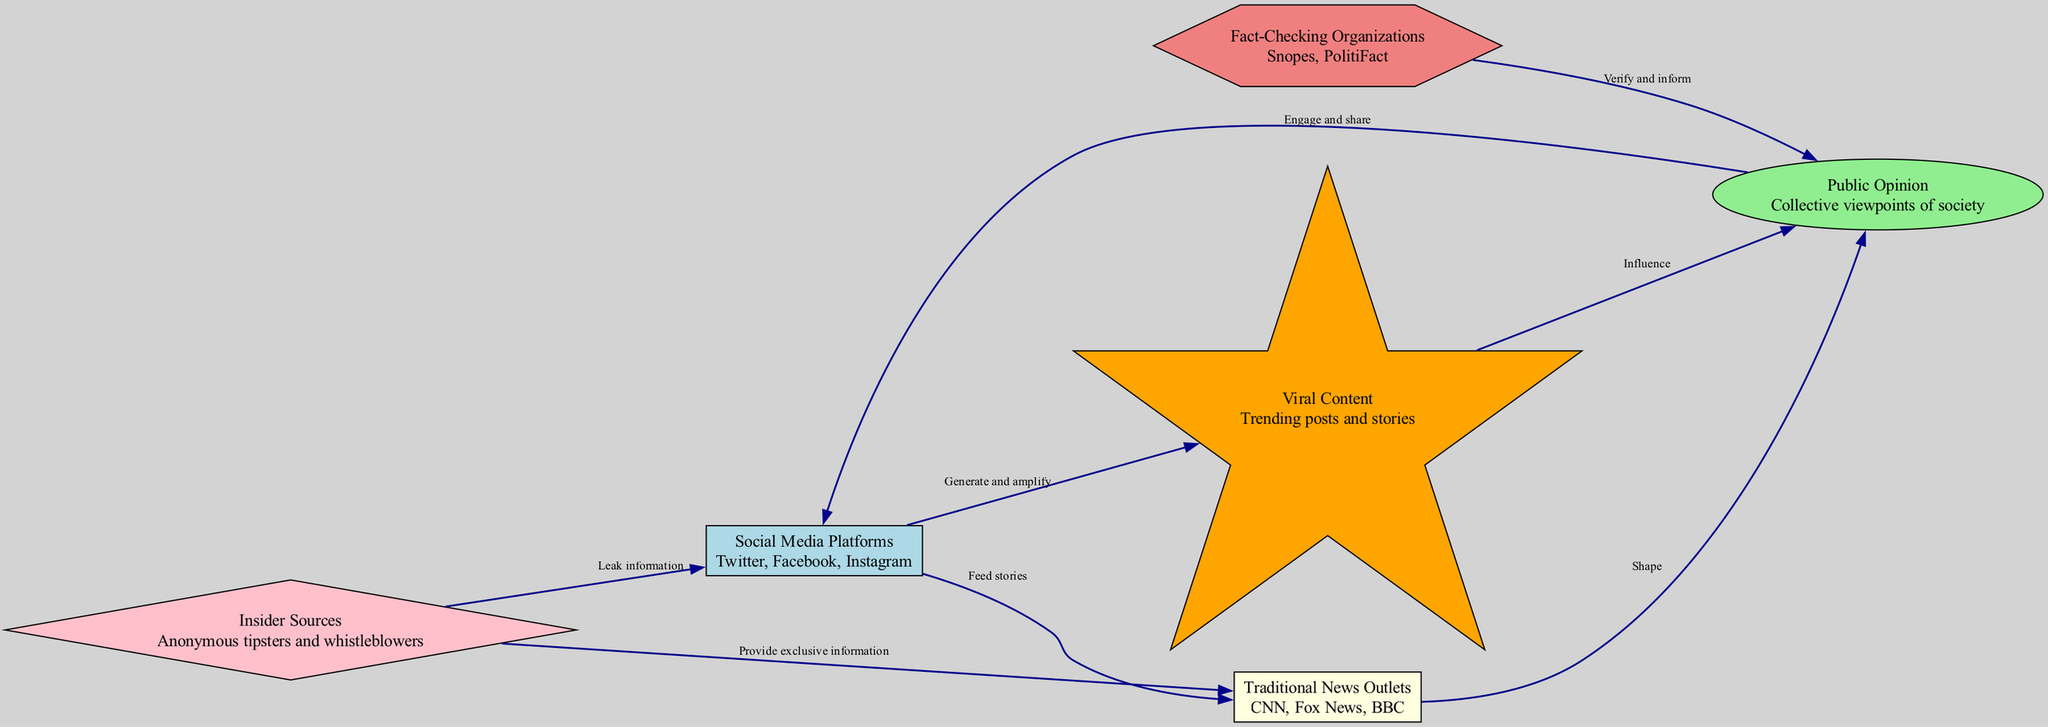What are the social media platforms listed in the diagram? The diagram describes "Social Media Platforms" including "Twitter, Facebook, Instagram" as their names. These are shown as nodes within the diagram and are part of the flow of information.
Answer: Twitter, Facebook, Instagram How many traditional news outlets are represented in the model? The diagram contains only one node labeled "Traditional News Outlets," which represents the category including several organizations like CNN, Fox News, and BBC. Thus, there is one primary node for this category.
Answer: 1 What type of relationship exists between traditional news outlets and public opinion? According to the diagram, traditional news outlets "Shape" public opinion, indicating that the relationship described is one where the news outlets have a significant influence on how public opinion is formed.
Answer: Shape Which node influences public opinion through viral content? The "Viral Content" node directly influences public opinion, as indicated by the edge labeled "Influence" that connects the two nodes. This shows that trending posts and stories play a role in shaping collective viewpoints in society.
Answer: Viral Content What mechanism does the insider source use to interact with social media platforms? The insider source "Leak information" to social media platforms, as depicted by the directed edge in the diagram. This indicates that insider sources provide confidential or exclusive information to social media platforms for further dissemination.
Answer: Leak information What is the function of fact-checking organizations in relation to public opinion? Fact-checking organizations "Verify and inform" public opinion, which implies that they play a critical role in ensuring the accuracy of information that shapes public viewpoints. This is represented by the edge directed towards public opinion from the fact-checking organizations.
Answer: Verify and inform How do social media platforms affect traditional news outlets? Social media platforms "Feed stories" to traditional news outlets, indicating that content generated on social media plays a role in driving the narratives that traditional news organizations report on. This relationship is illustrated by the connecting edge.
Answer: Feed stories How many nodes are involved in the insider source's connections? The insider source connects to both the "Social Media Platforms" and "Traditional News Outlets," making a total of two nodes in its direct influence sphere. Each of these represents a way in which insider information can be disseminated to public audiences.
Answer: 2 